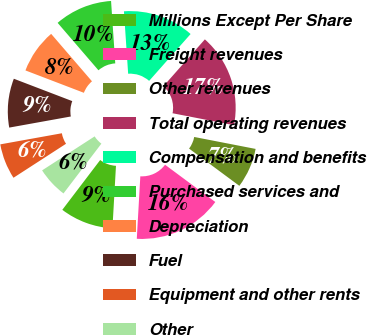<chart> <loc_0><loc_0><loc_500><loc_500><pie_chart><fcel>Millions Except Per Share<fcel>Freight revenues<fcel>Other revenues<fcel>Total operating revenues<fcel>Compensation and benefits<fcel>Purchased services and<fcel>Depreciation<fcel>Fuel<fcel>Equipment and other rents<fcel>Other<nl><fcel>9.45%<fcel>15.75%<fcel>7.09%<fcel>16.53%<fcel>12.6%<fcel>10.24%<fcel>7.87%<fcel>8.66%<fcel>6.3%<fcel>5.51%<nl></chart> 